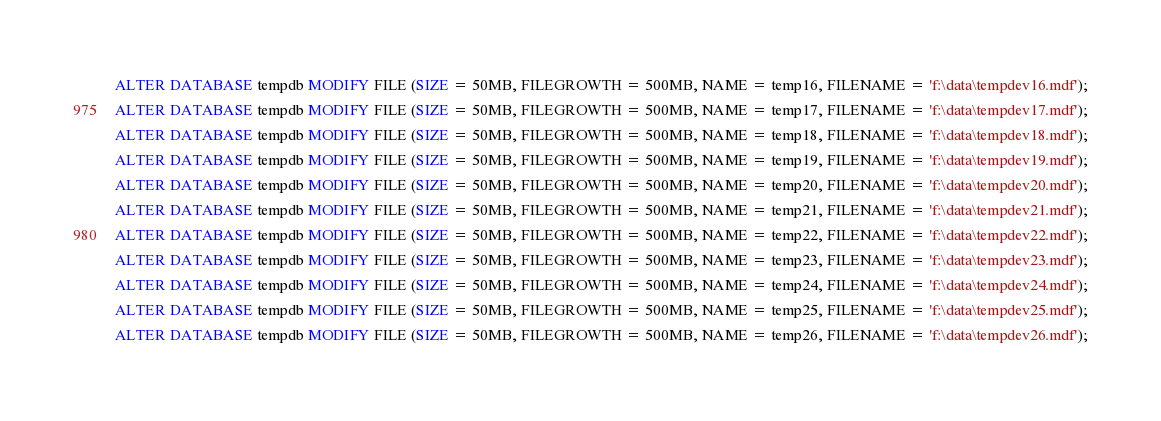<code> <loc_0><loc_0><loc_500><loc_500><_SQL_>ALTER DATABASE tempdb MODIFY FILE (SIZE = 50MB, FILEGROWTH = 500MB, NAME = temp16, FILENAME = 'f:\data\tempdev16.mdf');
ALTER DATABASE tempdb MODIFY FILE (SIZE = 50MB, FILEGROWTH = 500MB, NAME = temp17, FILENAME = 'f:\data\tempdev17.mdf');
ALTER DATABASE tempdb MODIFY FILE (SIZE = 50MB, FILEGROWTH = 500MB, NAME = temp18, FILENAME = 'f:\data\tempdev18.mdf');
ALTER DATABASE tempdb MODIFY FILE (SIZE = 50MB, FILEGROWTH = 500MB, NAME = temp19, FILENAME = 'f:\data\tempdev19.mdf');
ALTER DATABASE tempdb MODIFY FILE (SIZE = 50MB, FILEGROWTH = 500MB, NAME = temp20, FILENAME = 'f:\data\tempdev20.mdf');
ALTER DATABASE tempdb MODIFY FILE (SIZE = 50MB, FILEGROWTH = 500MB, NAME = temp21, FILENAME = 'f:\data\tempdev21.mdf');
ALTER DATABASE tempdb MODIFY FILE (SIZE = 50MB, FILEGROWTH = 500MB, NAME = temp22, FILENAME = 'f:\data\tempdev22.mdf');
ALTER DATABASE tempdb MODIFY FILE (SIZE = 50MB, FILEGROWTH = 500MB, NAME = temp23, FILENAME = 'f:\data\tempdev23.mdf');
ALTER DATABASE tempdb MODIFY FILE (SIZE = 50MB, FILEGROWTH = 500MB, NAME = temp24, FILENAME = 'f:\data\tempdev24.mdf');
ALTER DATABASE tempdb MODIFY FILE (SIZE = 50MB, FILEGROWTH = 500MB, NAME = temp25, FILENAME = 'f:\data\tempdev25.mdf');
ALTER DATABASE tempdb MODIFY FILE (SIZE = 50MB, FILEGROWTH = 500MB, NAME = temp26, FILENAME = 'f:\data\tempdev26.mdf');</code> 